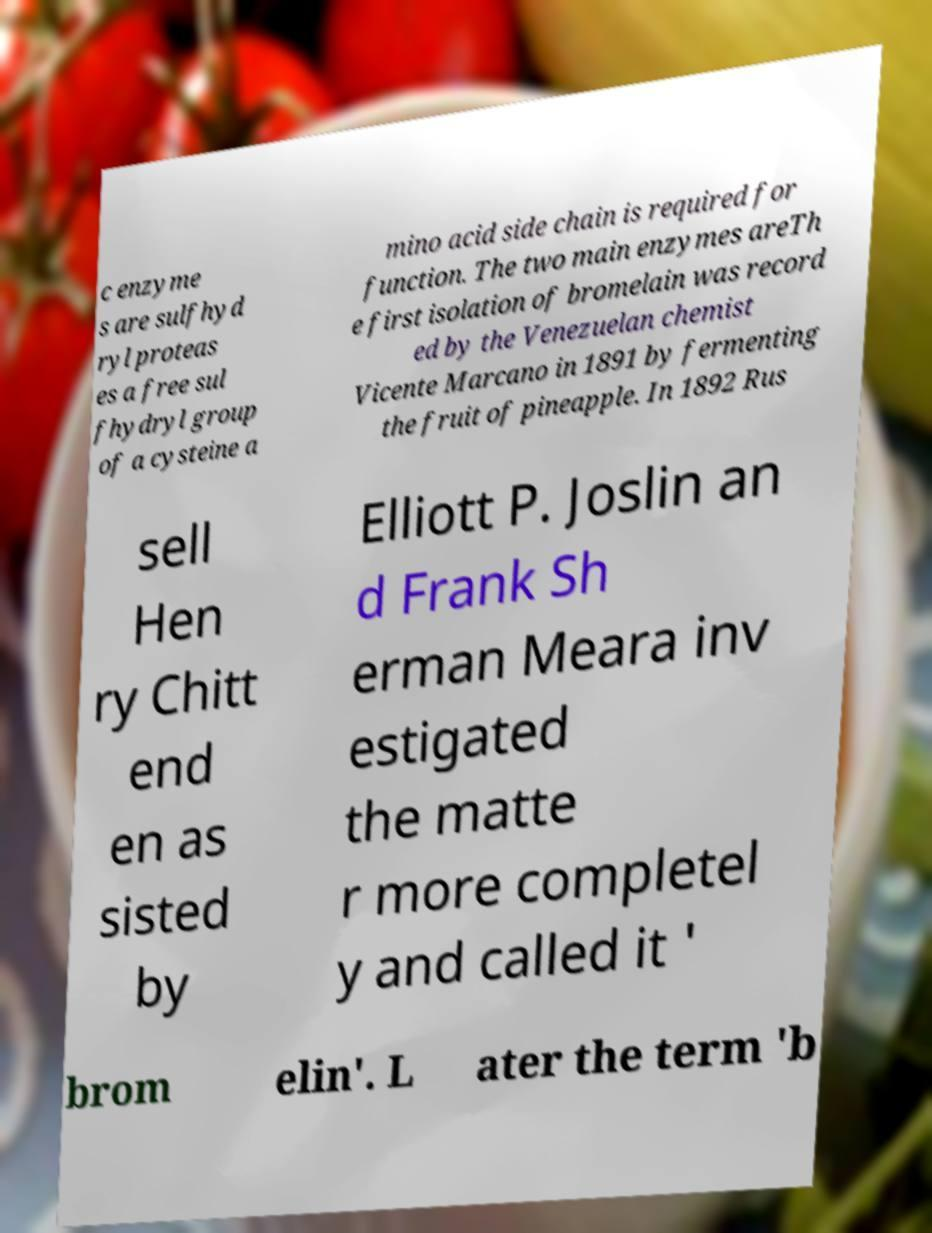Can you read and provide the text displayed in the image?This photo seems to have some interesting text. Can you extract and type it out for me? c enzyme s are sulfhyd ryl proteas es a free sul fhydryl group of a cysteine a mino acid side chain is required for function. The two main enzymes areTh e first isolation of bromelain was record ed by the Venezuelan chemist Vicente Marcano in 1891 by fermenting the fruit of pineapple. In 1892 Rus sell Hen ry Chitt end en as sisted by Elliott P. Joslin an d Frank Sh erman Meara inv estigated the matte r more completel y and called it ' brom elin'. L ater the term 'b 